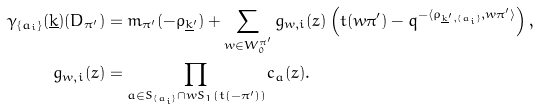<formula> <loc_0><loc_0><loc_500><loc_500>\gamma _ { \{ a _ { i } \} } ( \underline { k } ) ( D _ { \pi ^ { \prime } } ) & = m _ { \pi ^ { \prime } } ( - \rho _ { \underline { k } ^ { \prime } } ) + \sum _ { w \in W _ { 0 } ^ { \pi ^ { \prime } } } g _ { w , i } ( z ) \left ( t ( w \pi ^ { \prime } ) - q ^ { - \langle \rho _ { \underline { k } ^ { \prime } , \{ a _ { i } \} } , w \pi ^ { \prime } \rangle } \right ) , \\ g _ { w , i } ( z ) & = \prod _ { a \in S _ { \{ a _ { i } \} } \cap w S _ { 1 } ( t ( - \pi ^ { \prime } ) ) } c _ { a } ( z ) .</formula> 